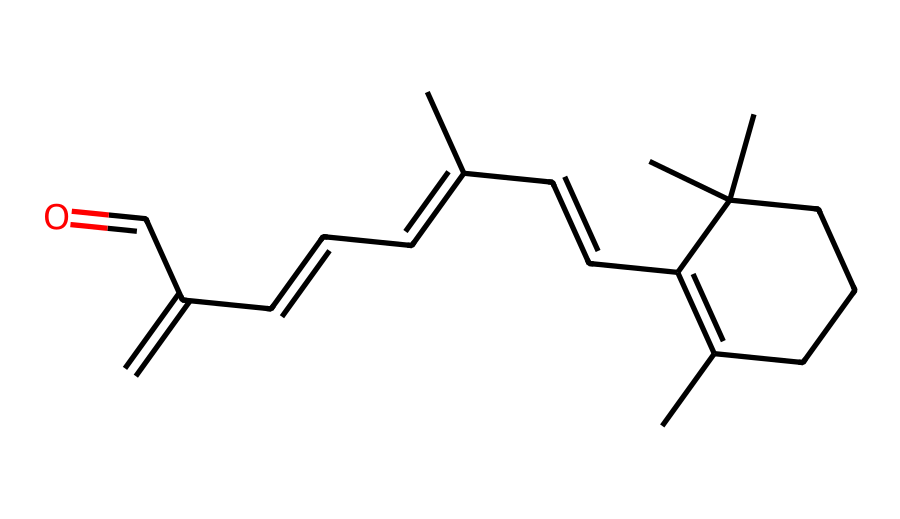What is the main functional group present in retinol? The SMILES representation indicates the presence of a carbonyl group (C=O) along with other structural features. The highest priority functional group is the aldehyde, which can be seen at the end of the chain.
Answer: aldehyde How many double bonds are present in the structure of retinol? By examining the SMILES representation, we can count each occurrence of a double bond. The structure has multiple instances of double bonds specifically within the carbon ring and in the side chains. The total count of double bonds is 5.
Answer: 5 What type of carbon skeleton does retinol have? The structure is primarily composed of a hydrocarbon chain with rings and branching, characteristic of steroids and terpenoids. Upon analyzing the connectivity of carbon atoms, we can conclude it has a tetracyclic structure.
Answer: tetracyclic Is retinol a saturated or unsaturated compound? Looking at the number of double bonds present in the structure confirms that there are multiple double bonds, indicating that this compound has unsaturations. Therefore, retinol is classified as unsaturated.
Answer: unsaturated What role does retinol play in skin care formulations? Based on its chemical properties and reactions, retinol is known to promote cell turnover and collagen production, making it essential in anti-aging formulations. This characteristic gives retinol its function in skin care products.
Answer: anti-aging How many rings are there in the chemical structure of retinol? Analyzing the cyclical part of the SMILES reveals one cyclohexene ring as the primary cyclical component in the molecular structure. Therefore, there is one ring present in retinol's structure.
Answer: 1 What vitamin class does retinol belong to? The structure reveals that retinol is a derivative of vitamin A, which is a crucial fat-soluble vitamin. This identification is based on the functional groups and structural characteristics associated with vitamin A-related compounds.
Answer: vitamin A 